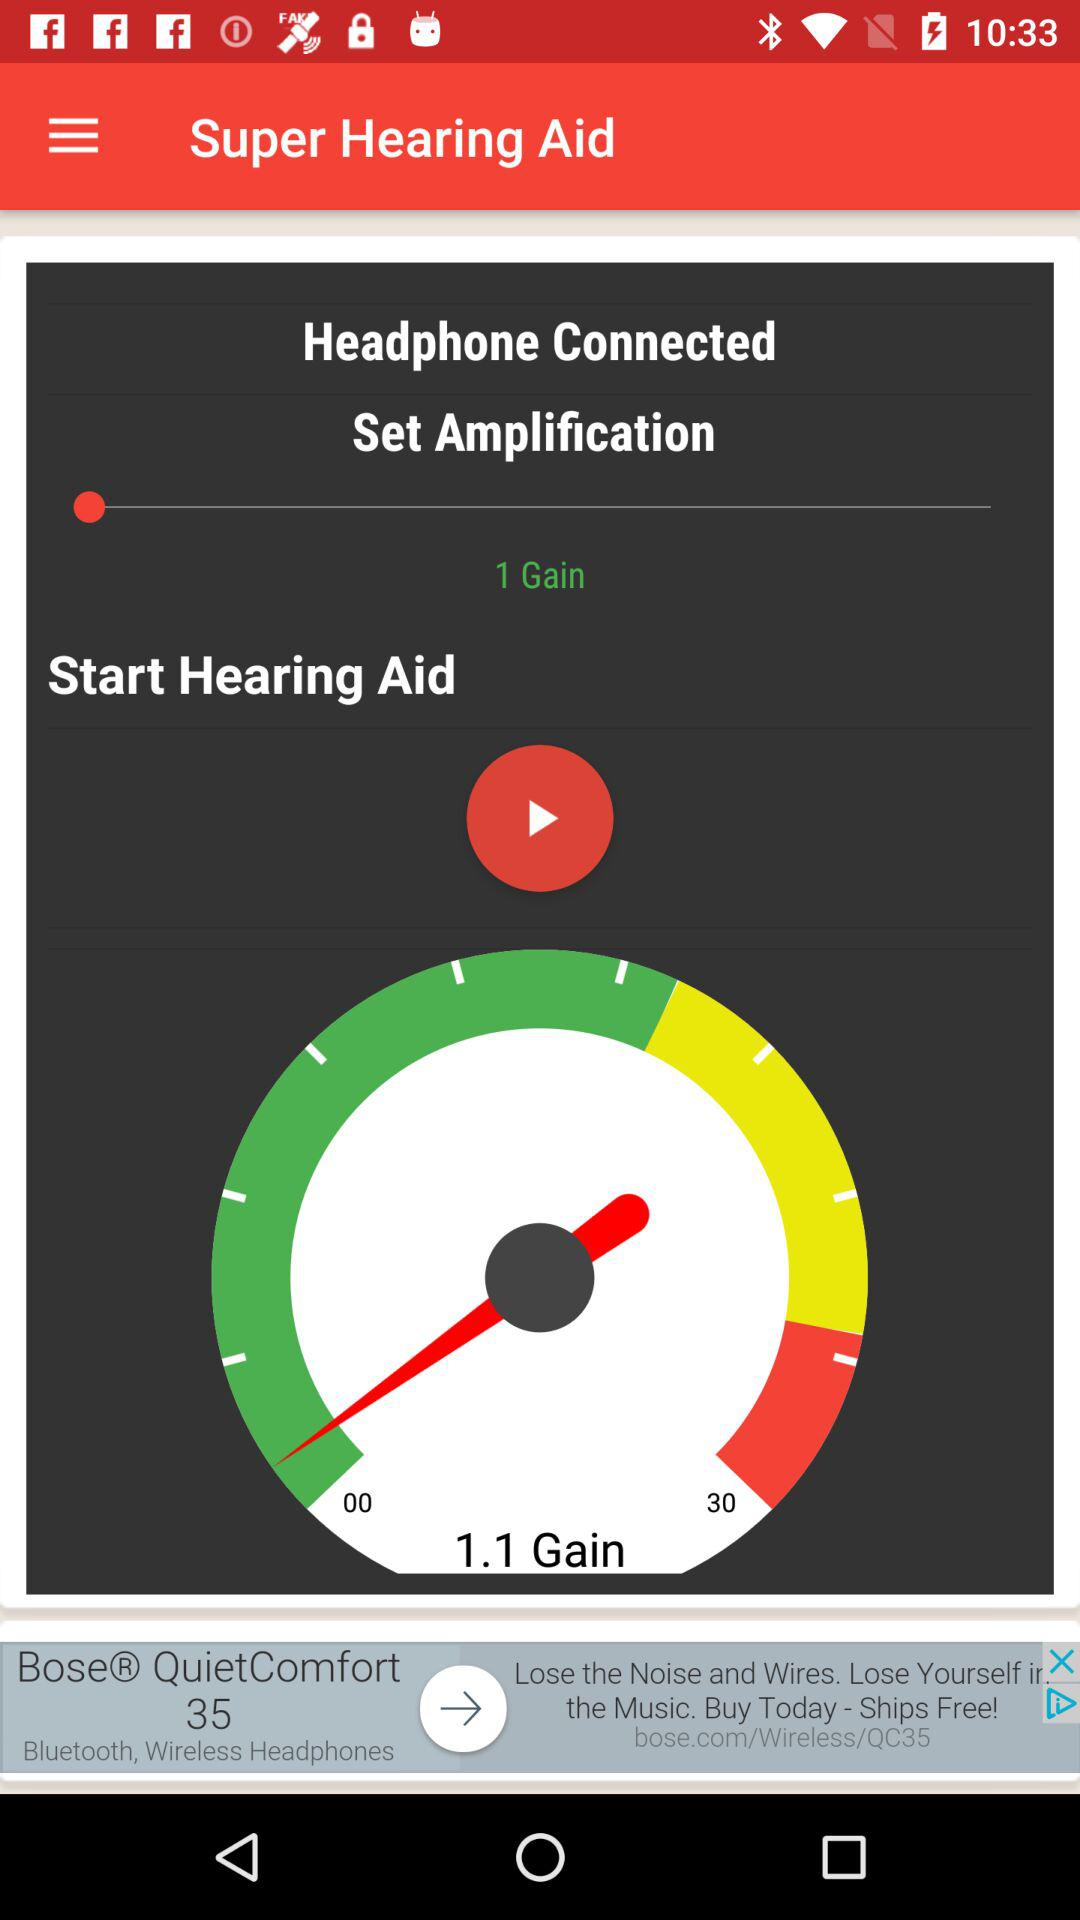What is the count of gain shown in the application? The count of gain is 1. 